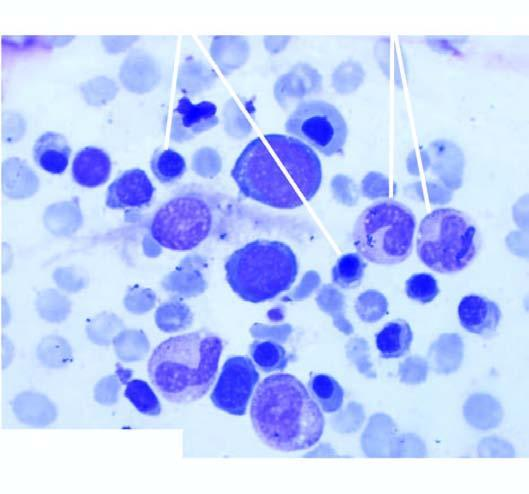s infarcted area moderate microcytosis and hypochromia?
Answer the question using a single word or phrase. No 